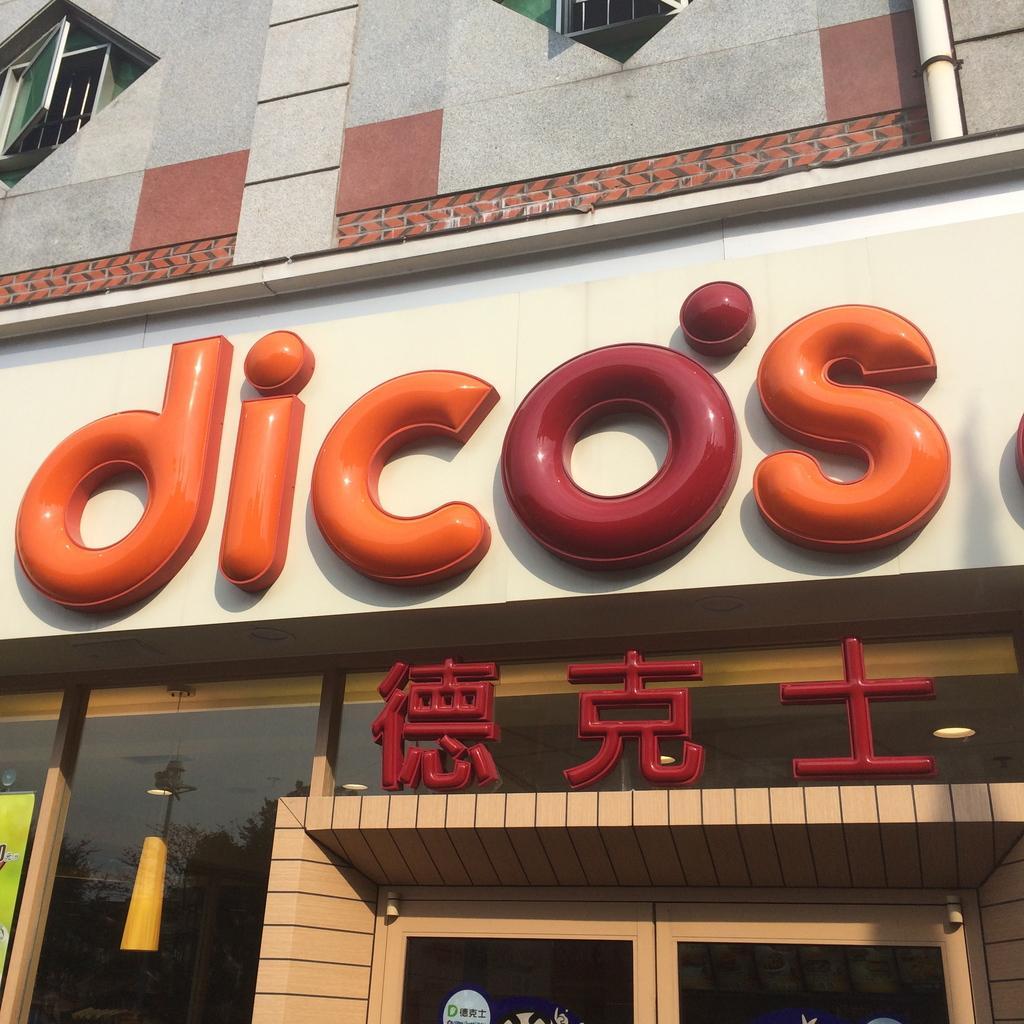In one or two sentences, can you explain what this image depicts? In this image we can see building, pipeline, windows, electric lights and a store. 